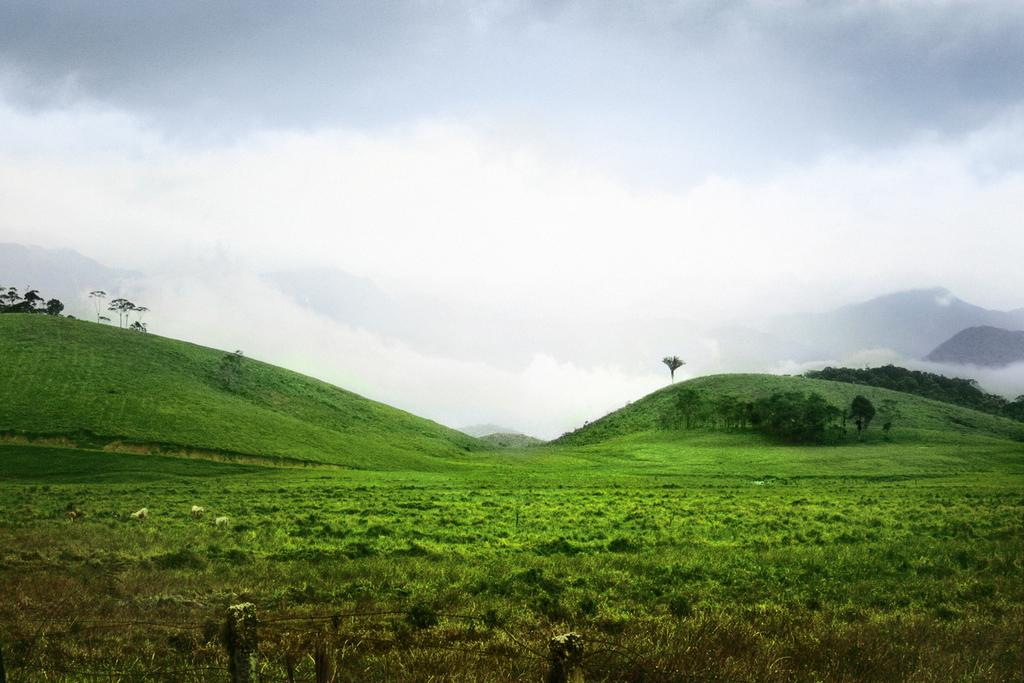What type of vegetation is present in the foreground of the image? There is grass in the foreground of the image. What can be seen on the cliffs in the background? There is greenery on the cliffs in the background. What is visible at the top of the image? Clouds are visible at the top of the image. What team is playing on the road in the image? There is no team or road present in the image; it features grass in the foreground, greenery on cliffs in the background, and clouds at the top. What type of detail can be seen on the road in the image? There is no road or detail related to a road present in the image. 